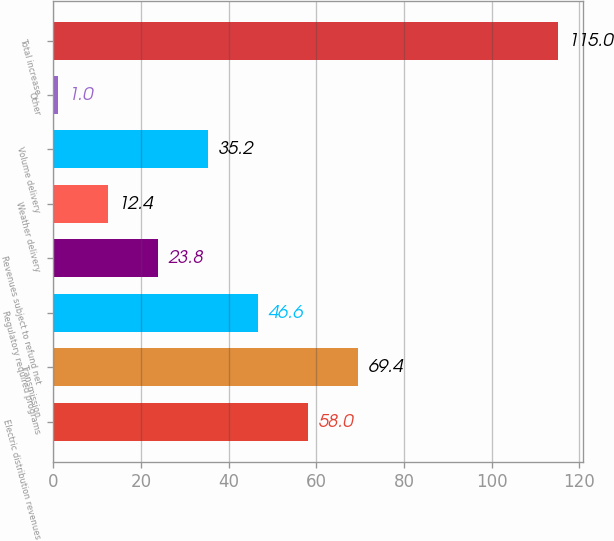Convert chart to OTSL. <chart><loc_0><loc_0><loc_500><loc_500><bar_chart><fcel>Electric distribution revenues<fcel>Transmission<fcel>Regulatory required programs<fcel>Revenues subject to refund net<fcel>Weather delivery<fcel>Volume delivery<fcel>Other<fcel>Total increase<nl><fcel>58<fcel>69.4<fcel>46.6<fcel>23.8<fcel>12.4<fcel>35.2<fcel>1<fcel>115<nl></chart> 